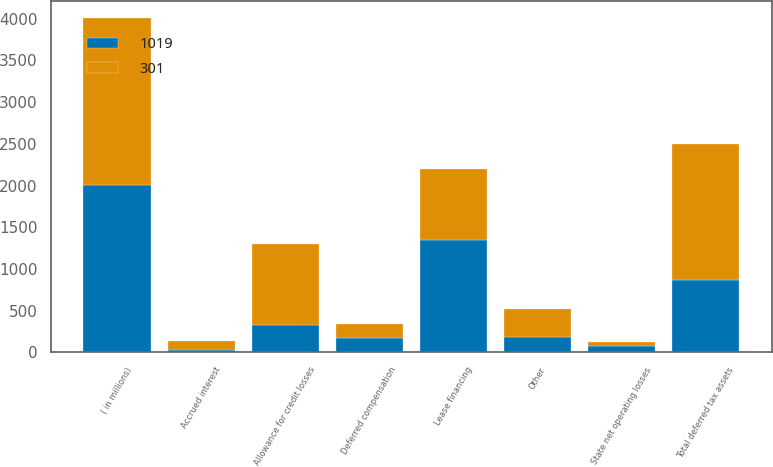<chart> <loc_0><loc_0><loc_500><loc_500><stacked_bar_chart><ecel><fcel>( in millions)<fcel>Allowance for credit losses<fcel>Deferred compensation<fcel>Accrued interest<fcel>State net operating losses<fcel>Other<fcel>Total deferred tax assets<fcel>Lease financing<nl><fcel>301<fcel>2008<fcel>975<fcel>171<fcel>104<fcel>58<fcel>328<fcel>1636<fcel>849<nl><fcel>1019<fcel>2007<fcel>328<fcel>174<fcel>33<fcel>72<fcel>188<fcel>863<fcel>1344<nl></chart> 